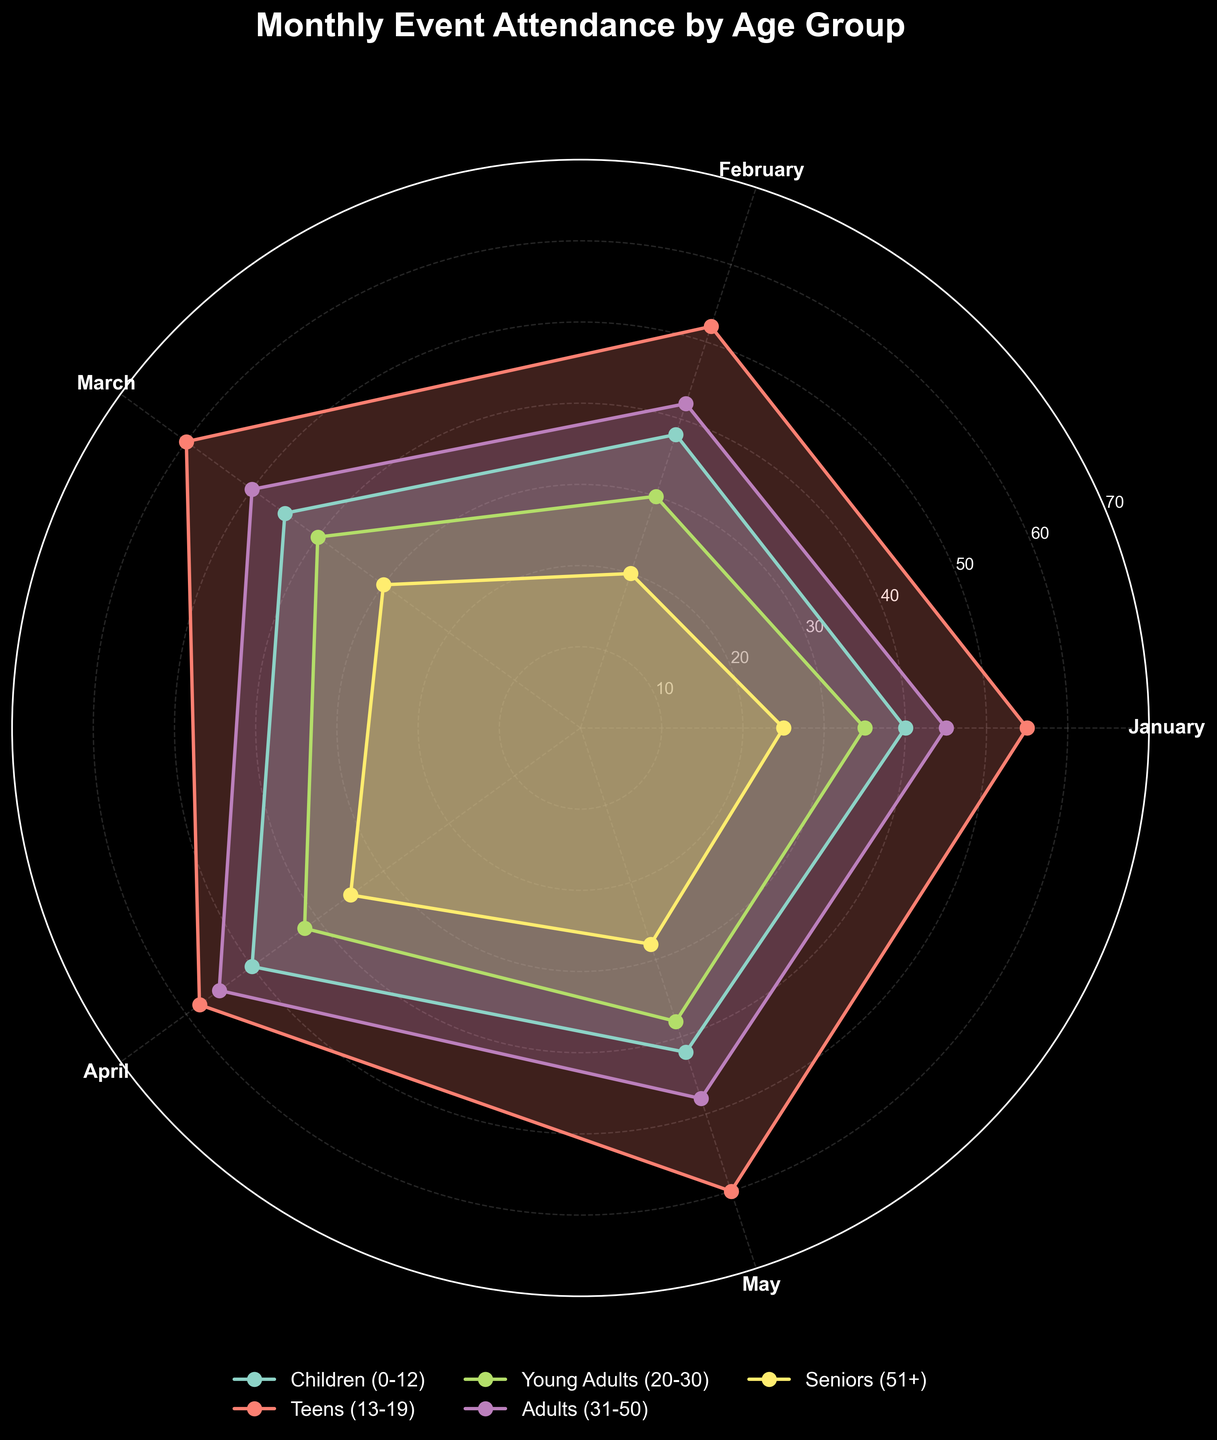What is the title of this polar area chart? The title of the chart is usually displayed at the top center of the plot. It is prominently shown to convey the main subject of the visualization.
Answer: Monthly Event Attendance by Age Group Which month had the highest attendance for Teens (13-19)? Look for the segment representing the Teens (13-19) age group, and identify which radial segment extends the furthest from the center among the months.
Answer: March How many age groups are represented in the chart? The legend of the chart or the different colors/polygons within the chart will help determine the number of unique age groups. Count the distinct groups listed.
Answer: 5 What age group had an attendance of 35 in April? Locate the segment corresponding to April and find the polygon reaching the attendance value of 35. Identify the color of this polygon and match it with the legend.
Answer: Seniors (51+) Which age group has the lowest attendance in February? Find the February segment and compare the lengths of the polygons for each age group. The shortest polygon in this segment corresponds to the lowest attendance.
Answer: Seniors (51+) How does the attendance for Children (0-12) change from January to May? Track the polygon for the Children (0-12) group across the months from January to May. Note the attendance values at each month: January (40), February (38), March (45), April (50), and May (42).
Answer: Initially decreases, then increases until April, and decreases again in May What is the average attendance for Young Adults (20-30) over the given months? Sum the attendance values for Young Adults (20-30) across all months and divide by the number of months. Calculations are 35 (Jan) + 30 (Feb) + 40 (Mar) + 42 (Apr) + 38 (May) = 185, then 185/5.
Answer: 37 Which month has the most diverse age group attendance (largest variance)? Observe the spread of attendance values within each month by comparing the lengths of all polygons within each month's segment. The month with the widest spread (greatest variance) in segment lengths likely has the most diverse attendance.
Answer: April Do more Adults (31-50) attend events in March or April? Compare the length of the polygon for the Adults (31-50) age group between March and April. The longer polygon indicates higher attendance.
Answer: April In which month is the difference between the highest and lowest attendance the greatest? For each month, identify the highest and lowest attendance values among all age groups. Calculate the difference and compare across months. Specifically, examine the variance in polygon lengths within each month's segment.
Answer: April 